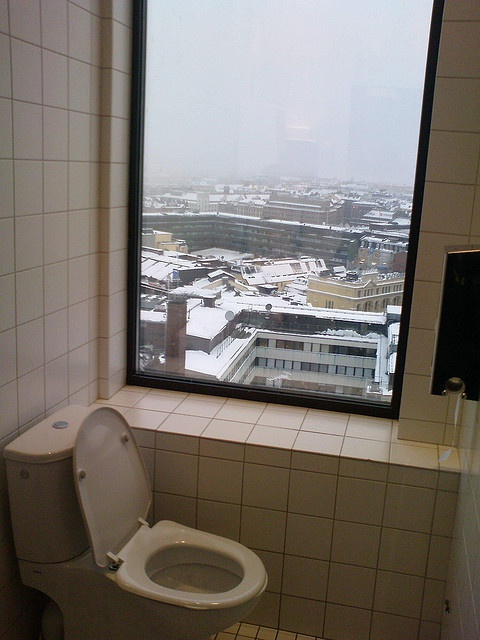Describe the objects in this image and their specific colors. I can see a toilet in gray and black tones in this image. 